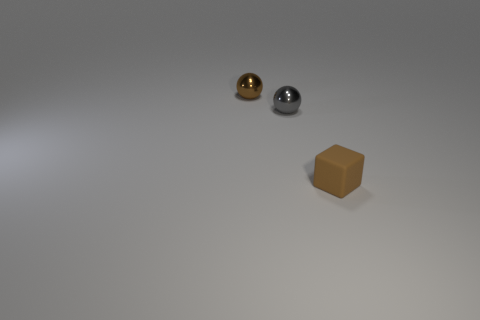Add 2 small gray spheres. How many objects exist? 5 Subtract all blocks. How many objects are left? 2 Subtract 0 yellow balls. How many objects are left? 3 Subtract all gray metal objects. Subtract all large cyan cylinders. How many objects are left? 2 Add 2 brown things. How many brown things are left? 4 Add 1 big metallic spheres. How many big metallic spheres exist? 1 